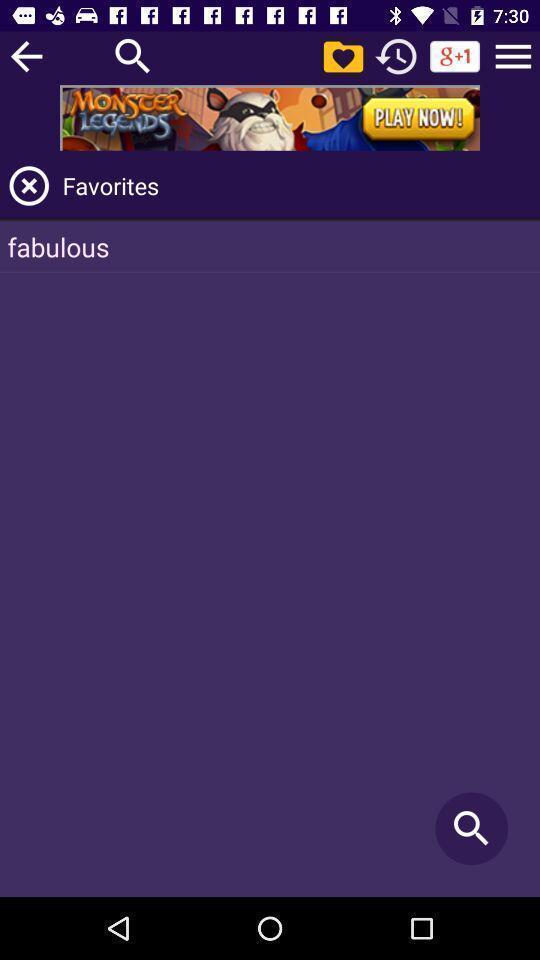Give me a summary of this screen capture. Search page for searching favorites. 